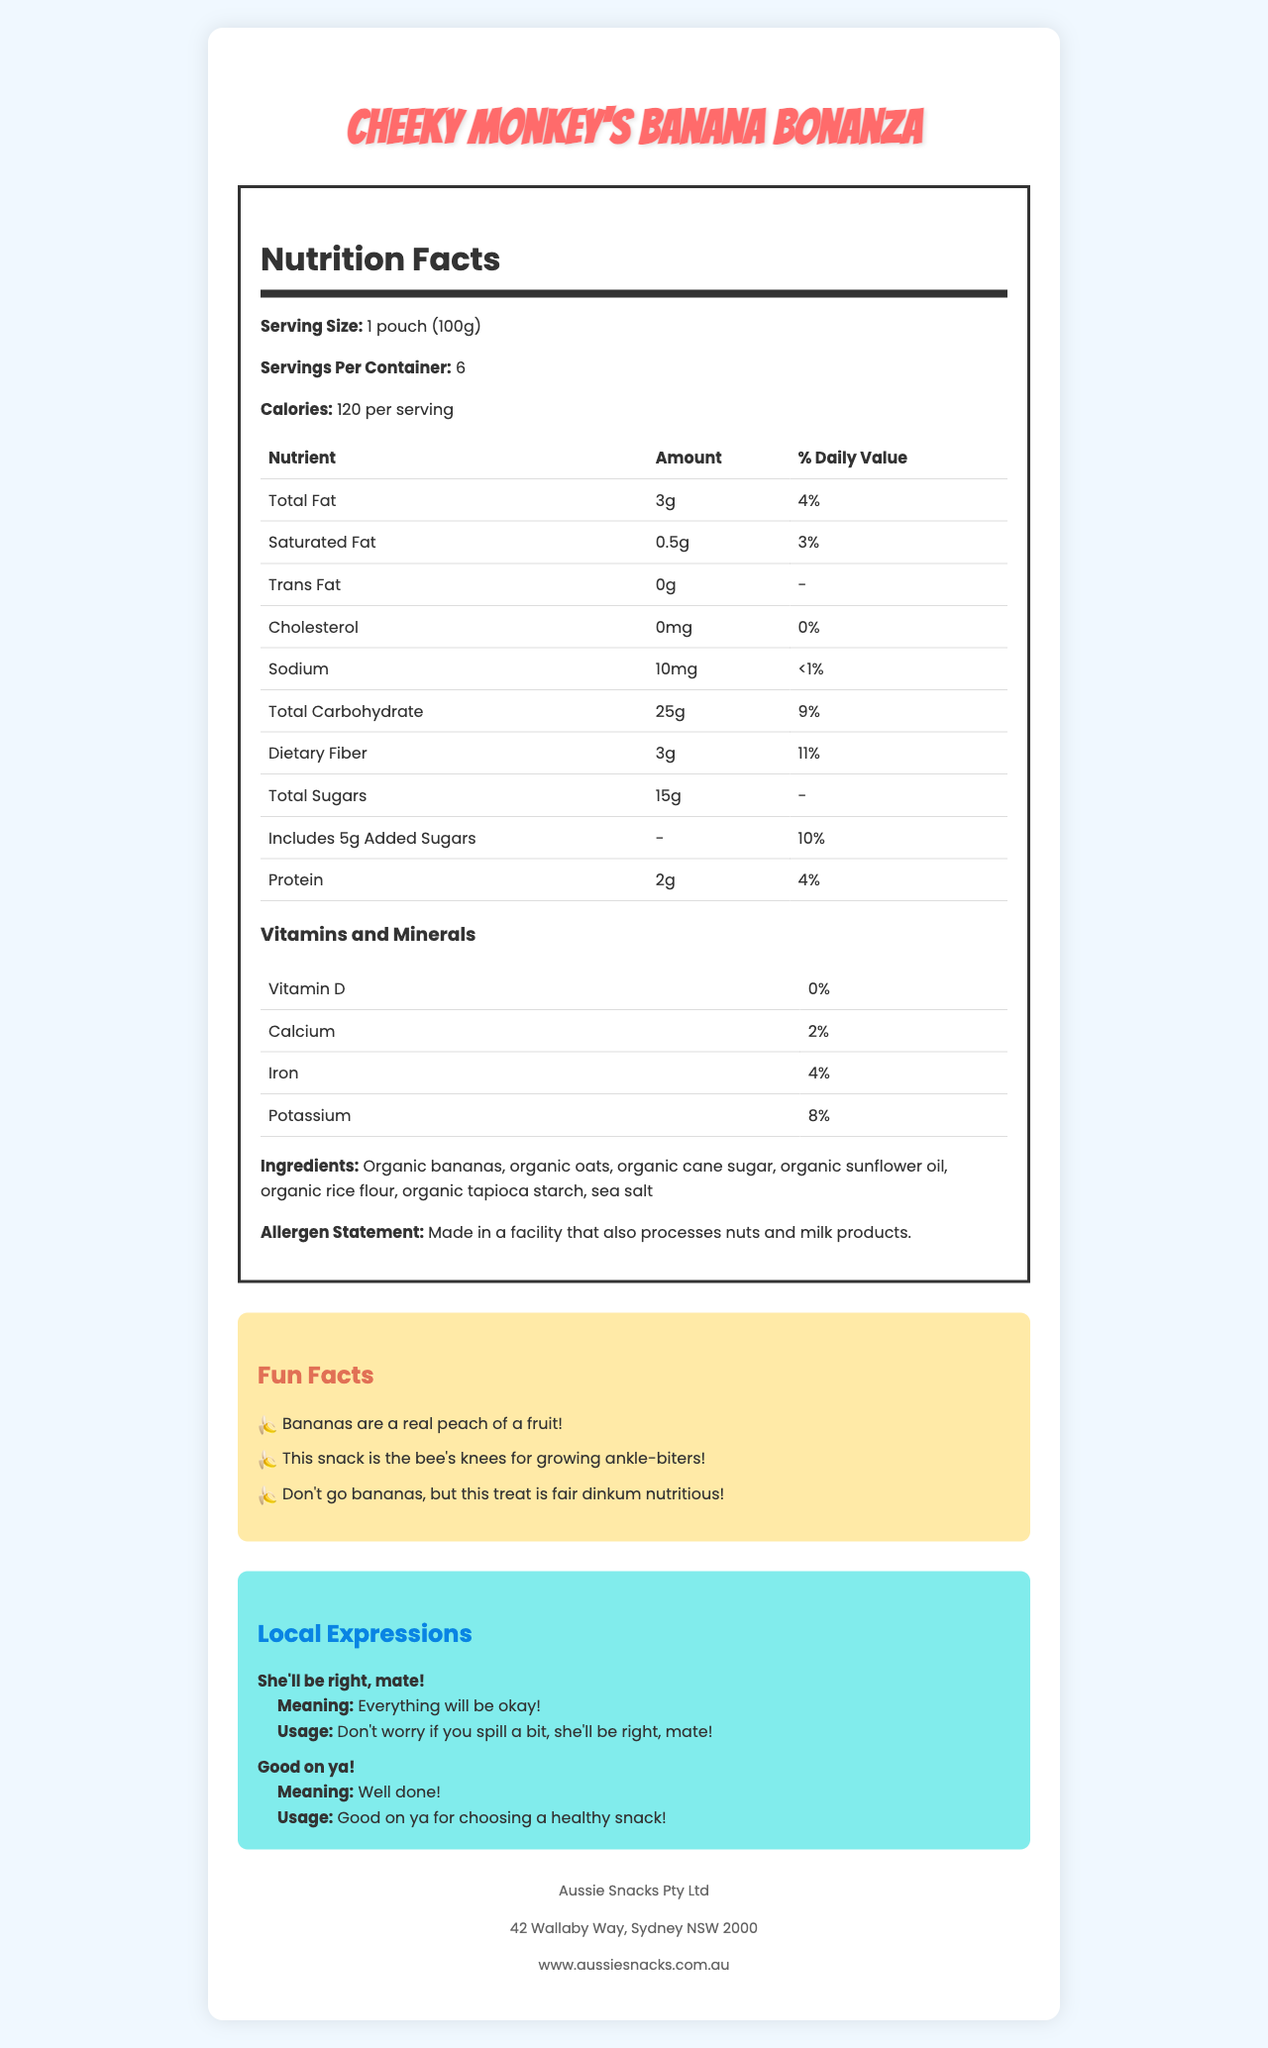what is the serving size for Cheeky Monkey's Banana Bonanza? The serving size is clearly stated in the Nutrition Facts section of the document.
Answer: 1 pouch (100g) how many calories are there per serving? The document states that there are 120 calories per serving in the Nutrition Facts section.
Answer: 120 what is the percentage of daily value provided by dietary fiber? In the Nutrition Facts panel, it is indicated that the daily value of dietary fiber per serving is 11%.
Answer: 11% which nutrient contributes 0% to the daily value? A. Iron B. Cholesterol C. Calcium The document shows that cholesterol has a 0% daily value contribution.
Answer: B how many servings are there per container? The serving information clearly states there are 6 servings per container.
Answer: 6 what is the total amount of sugars in one serving? According to the Nutrition Facts, the total sugars amount to 15g per serving.
Answer: 15g does this snack contain any trans fat? The document indicates that the amount of trans fat is 0g, meaning there is no trans fat in the snack.
Answer: No summarize the main details of this document. The document is comprehensive, covering the nutritional composition, fun and engaging facts about the snack, common local expressions, and manufacturer details.
Answer: The document provides detailed nutritional information for Cheeky Monkey's Banana Bonanza, including serving size, calories, and nutrient breakdown. It lists the fun facts, local expressions, the manufacturer’s information, and an allergen statement. which ingredient is not mentioned in Cheeky Monkey's Banana Bonanza? A. Organic bananas B. Organic sugar cane C. Organic almonds D. Organic oats The ingredients list includes items such as organic bananas, organic oats, and organic cane sugar but does not mention organic almonds.
Answer: C where is Aussie Snacks Pty Ltd based? The manufacturer information section provides the address of Aussie Snacks Pty Ltd.
Answer: 42 Wallaby Way, Sydney NSW 2000 what is the website of the manufacturer? The manufacturer’s information section lists the website as www.aussiesnacks.com.au.
Answer: www.aussiesnacks.com.au what is the meaning of "She'll be right, mate!"? The local expressions section explains that "She'll be right, mate!" means everything will be okay.
Answer: Everything will be okay! how much sodium is in one serving? The Nutrition Facts indicate there are 10mg of sodium per serving.
Answer: 10mg how many grams of protein are there in one pouch? According to the Nutrition Facts, there are 2g of protein in one pouch serving.
Answer: 2g does this document indicate the expiration date of the product? The document does not provide any information regarding the expiration date of Cheeky Monkey's Banana Bonanza.
Answer: Not enough information 